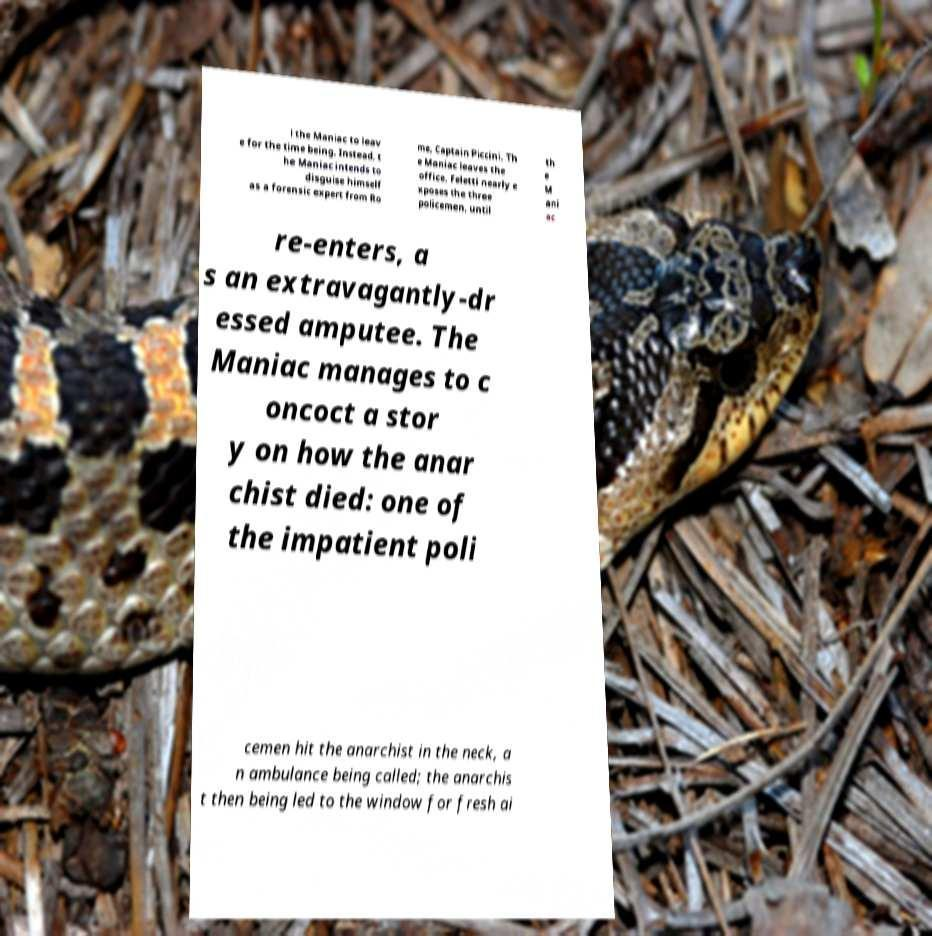Could you assist in decoding the text presented in this image and type it out clearly? l the Maniac to leav e for the time being. Instead, t he Maniac intends to disguise himself as a forensic expert from Ro me, Captain Piccini. Th e Maniac leaves the office. Feletti nearly e xposes the three policemen, until th e M ani ac re-enters, a s an extravagantly-dr essed amputee. The Maniac manages to c oncoct a stor y on how the anar chist died: one of the impatient poli cemen hit the anarchist in the neck, a n ambulance being called; the anarchis t then being led to the window for fresh ai 